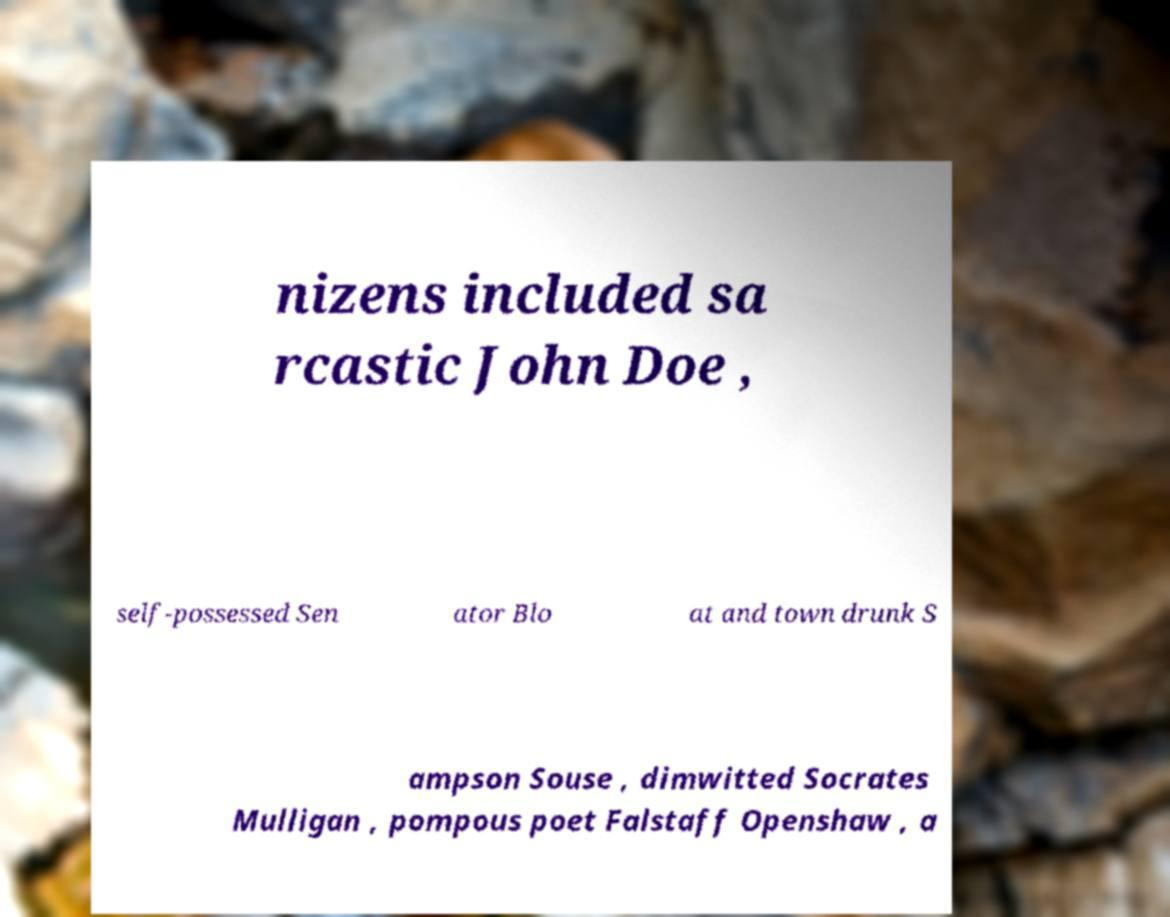Please read and relay the text visible in this image. What does it say? nizens included sa rcastic John Doe , self-possessed Sen ator Blo at and town drunk S ampson Souse , dimwitted Socrates Mulligan , pompous poet Falstaff Openshaw , a 